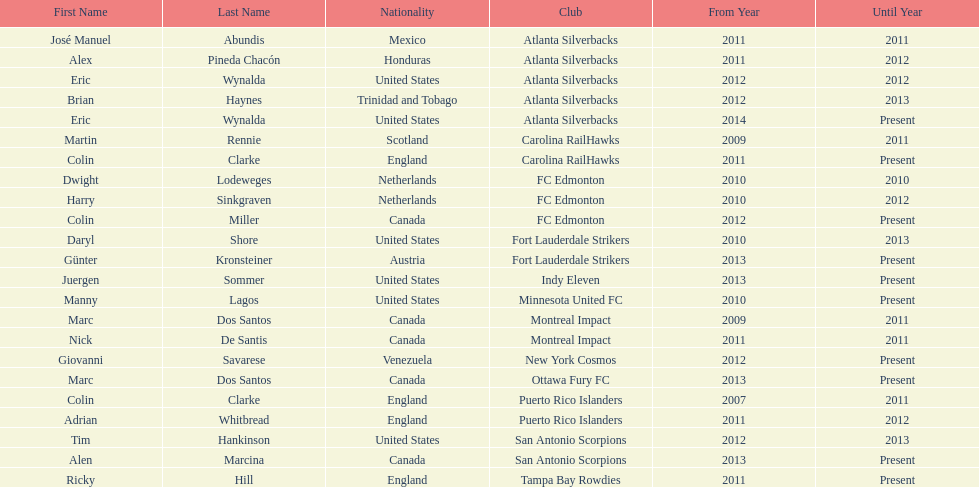Marc dos santos started as coach the same year as what other coach? Martin Rennie. 